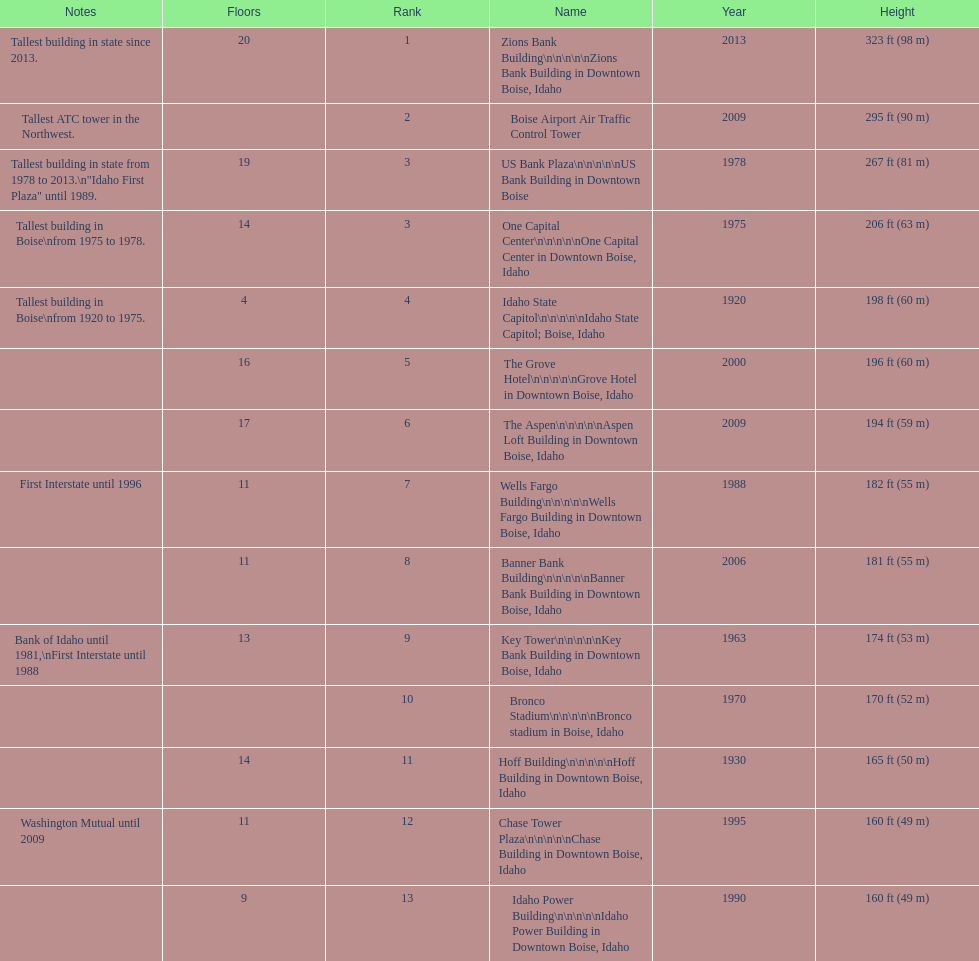How many floors does the tallest building have? 20. 